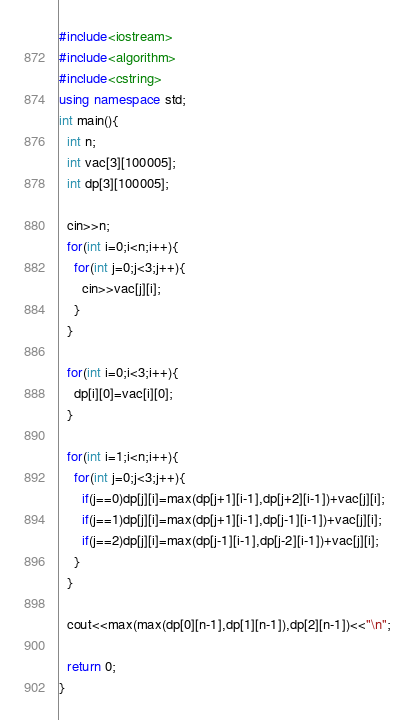Convert code to text. <code><loc_0><loc_0><loc_500><loc_500><_C++_>#include<iostream>
#include<algorithm>
#include<cstring>
using namespace std;
int main(){
  int n;
  int vac[3][100005];
  int dp[3][100005];
  
  cin>>n;
  for(int i=0;i<n;i++){
    for(int j=0;j<3;j++){
      cin>>vac[j][i];
    }
  }
  
  for(int i=0;i<3;i++){
    dp[i][0]=vac[i][0];
  }

  for(int i=1;i<n;i++){
    for(int j=0;j<3;j++){
      if(j==0)dp[j][i]=max(dp[j+1][i-1],dp[j+2][i-1])+vac[j][i];
      if(j==1)dp[j][i]=max(dp[j+1][i-1],dp[j-1][i-1])+vac[j][i];
      if(j==2)dp[j][i]=max(dp[j-1][i-1],dp[j-2][i-1])+vac[j][i];
    }
  }
  
  cout<<max(max(dp[0][n-1],dp[1][n-1]),dp[2][n-1])<<"\n";

  return 0;
}
</code> 